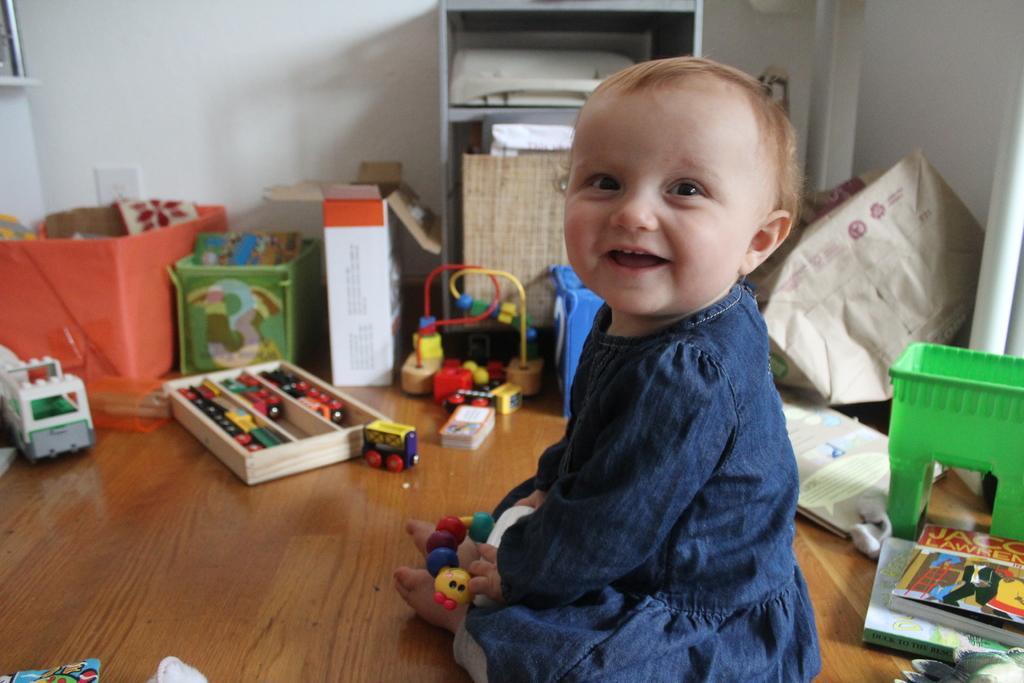Please provide a concise description of this image. In this image we can see a kid is sitting on the floor and holding a toy in the hands. There are toys and objects in the carton boxes are on the floor. We can see other objects, poles on the right side and wall. 